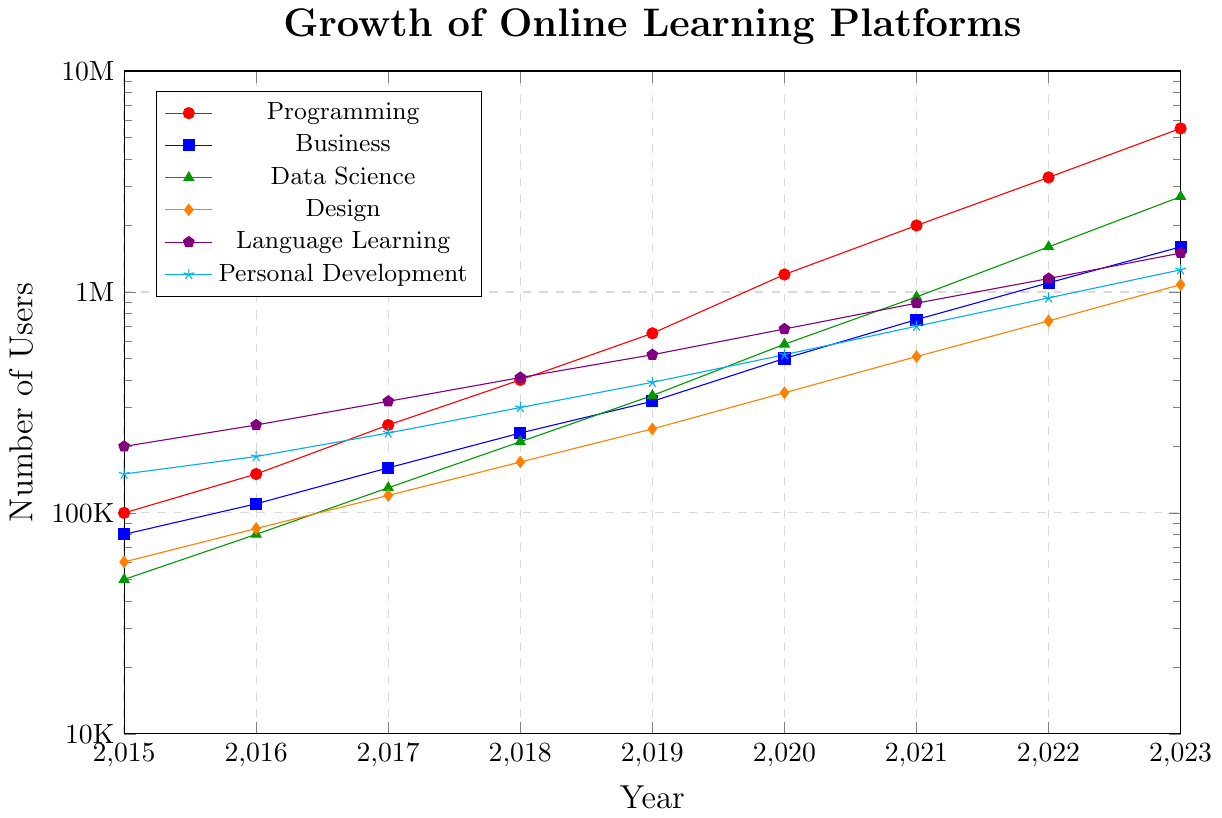What's the growth rate of users for Programming courses from 2015 to 2023? To find the growth rate, we use the formula: [(final value - initial value) / initial value] * 100. For Programming courses, the initial value in 2015 is 100,000, and the final value in 2023 is 5,500,000. The growth rate is [(5,500,000 - 100,000) / 100,000] * 100 = 5400%
Answer: 5400% Which subject area had the highest user base in 2023? From the chart, the subject with the highest value in 2023 can be identified visually. Programming had the highest user base with 5,500,000 users.
Answer: Programming Between 2018 and 2020, which subject area shows the steepest growth in users? To determine the steepest growth visually, we look at the lines between 2018 and 2020. The Programming subject shows the tallest increase from 400,000 in 2018 to 1,200,000 in 2020.
Answer: Programming Compare the user base of Data Science to Design in 2021. Which one has more users and by how much? In 2021, Data Science had 950,000 users, while Design had 510,000 users. The difference is 950,000 - 510,000 = 440,000. Data Science had 440,000 more users than Design.
Answer: Data Science by 440,000 What is the average annual growth rate for Business users from 2015 to 2023? First, calculate the total growth by subtracting the initial value (80,000 in 2015) from the final value (1,600,000 in 2023). Then, divide this growth by the number of years (2023 - 2015 = 8 years) to find the average annual growth: (1,600,000 - 80,000) / 8 = 190,000 users per year.
Answer: 190,000 users/year In which year did Personal Development exceed 1 million users? From the chart, Personal Development reached 1,260,000 users in 2023. The year it first exceeded 1 million was just before 2023.
Answer: 2023 Which subject area had the smallest user base in 2017? Visually, based on the data points in 2017, Data Science had the smallest user base with 130,000 users.
Answer: Data Science By how many users did Business grow from 2017 to 2023? The user base for Business in 2017 was 160,000 and in 2023 it was 1,600,000. The growth is calculated as 1,600,000 - 160,000 = 1,440,000 users.
Answer: 1,440,000 users How do the user bases of Language Learning and Design compare in 2019? In 2019, the user base for Language Learning was 520,000, while for Design it was 240,000. Language Learning had 520,000 - 240,000 = 280,000 more users than Design.
Answer: Language Learning by 280,000 